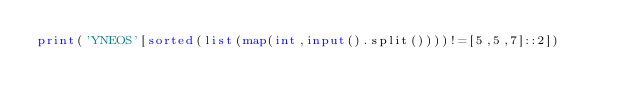<code> <loc_0><loc_0><loc_500><loc_500><_Python_>print('YNEOS'[sorted(list(map(int,input().split())))!=[5,5,7]::2])</code> 